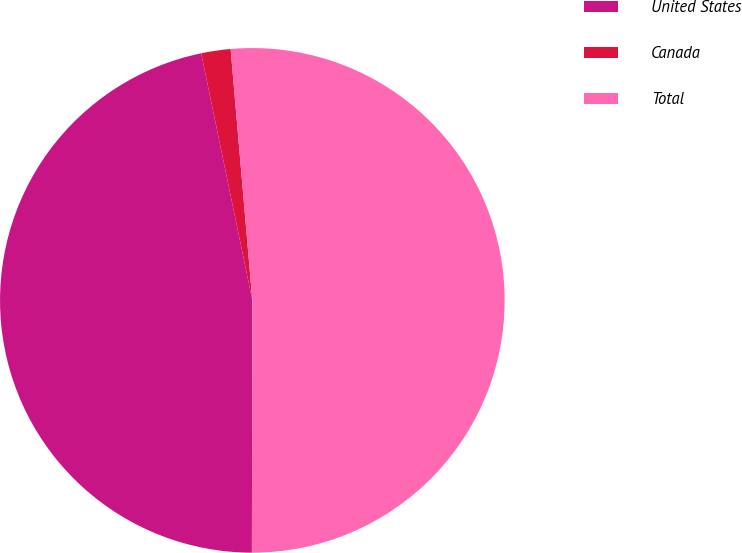Convert chart to OTSL. <chart><loc_0><loc_0><loc_500><loc_500><pie_chart><fcel>United States<fcel>Canada<fcel>Total<nl><fcel>46.72%<fcel>1.88%<fcel>51.4%<nl></chart> 